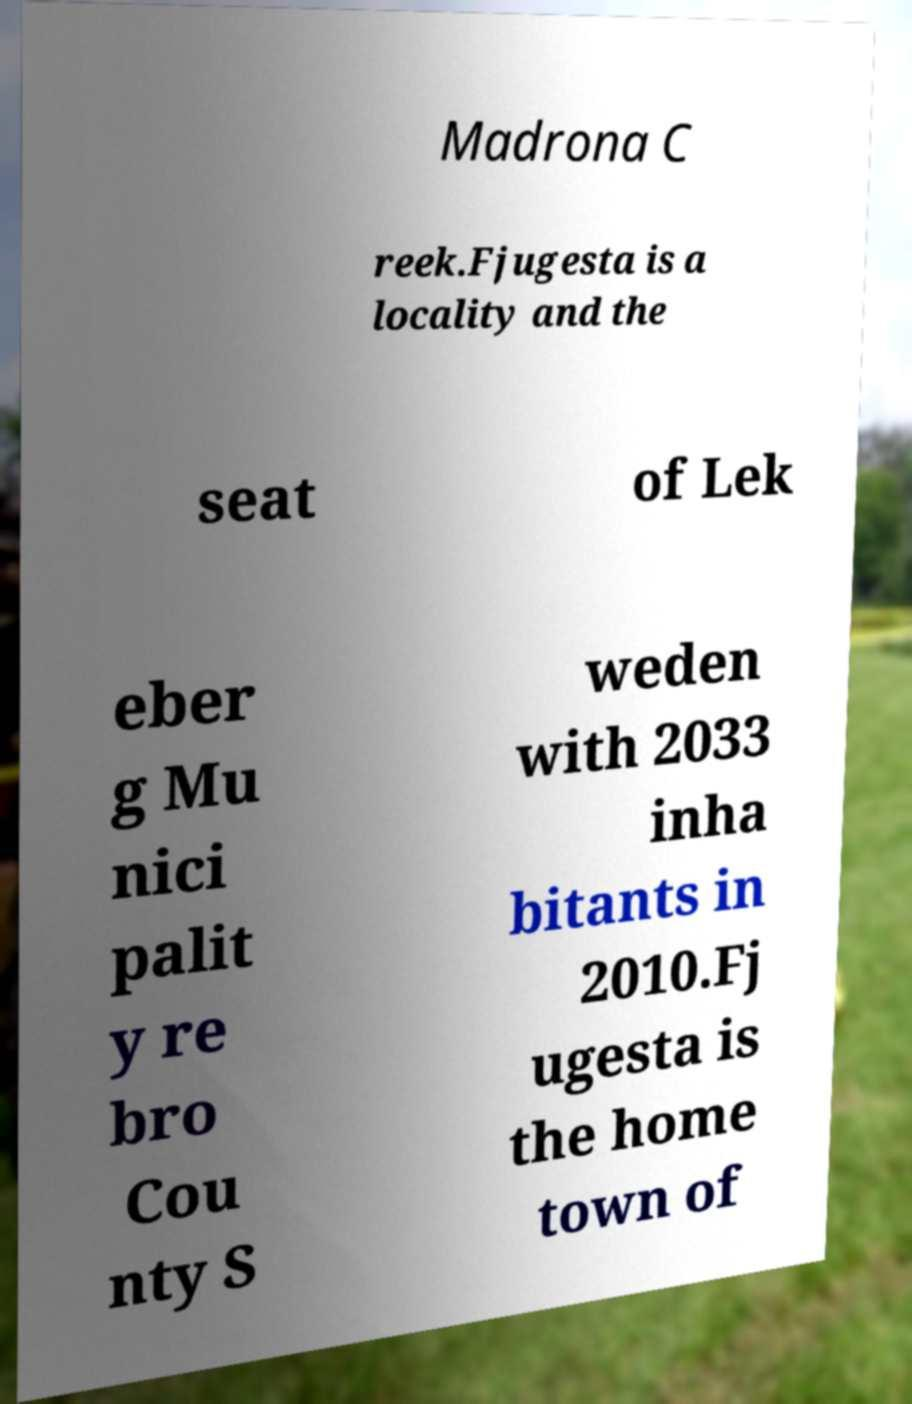Please identify and transcribe the text found in this image. Madrona C reek.Fjugesta is a locality and the seat of Lek eber g Mu nici palit y re bro Cou nty S weden with 2033 inha bitants in 2010.Fj ugesta is the home town of 